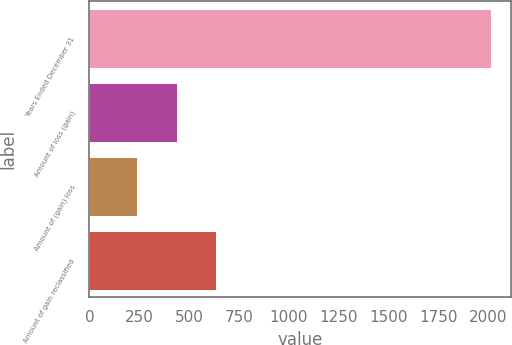Convert chart. <chart><loc_0><loc_0><loc_500><loc_500><bar_chart><fcel>Years Ended December 31<fcel>Amount of loss (gain)<fcel>Amount of (gain) loss<fcel>Amount of gain reclassified<nl><fcel>2017<fcel>437.8<fcel>240.4<fcel>635.2<nl></chart> 